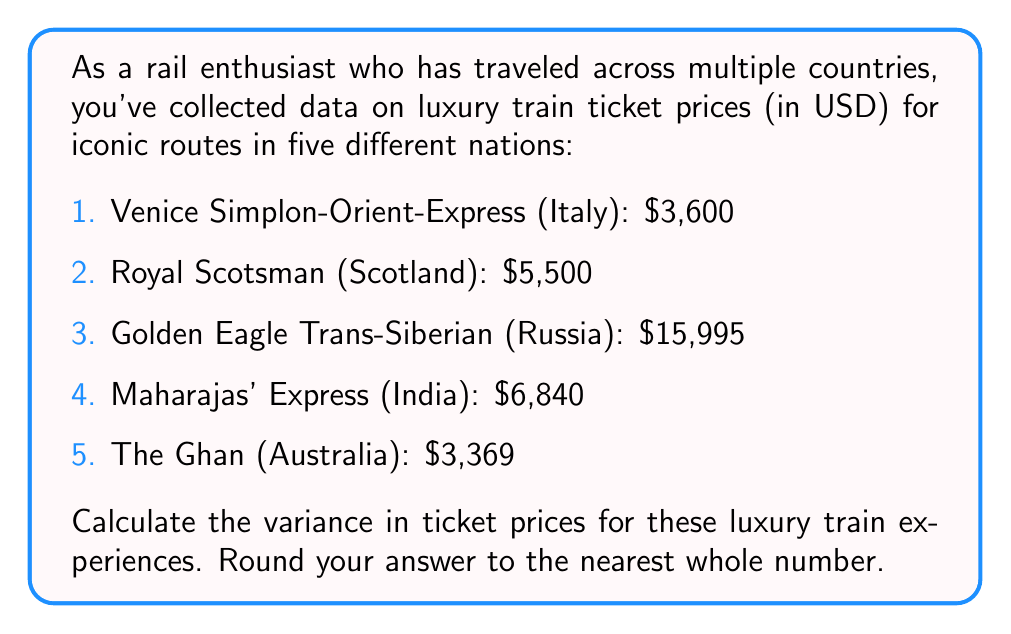Solve this math problem. To calculate the variance, we'll follow these steps:

1. Calculate the mean ticket price:
   $$\mu = \frac{3600 + 5500 + 15995 + 6840 + 3369}{5} = 7060.8$$

2. Calculate the squared differences from the mean:
   $$(3600 - 7060.8)^2 = 11,961,856.04$$
   $$(5500 - 7060.8)^2 = 2,435,462.44$$
   $$(15995 - 7060.8)^2 = 79,553,960.04$$
   $$(6840 - 7060.8)^2 = 48,841.44$$
   $$(3369 - 7060.8)^2 = 13,620,460.84$$

3. Sum the squared differences:
   $$11,961,856.04 + 2,435,462.44 + 79,553,960.04 + 48,841.44 + 13,620,460.84 = 107,620,580.8$$

4. Divide by the number of data points (5) to get the variance:
   $$\text{Variance} = \frac{107,620,580.8}{5} = 21,524,116.16$$

5. Round to the nearest whole number:
   $$21,524,116$$
Answer: 21,524,116 